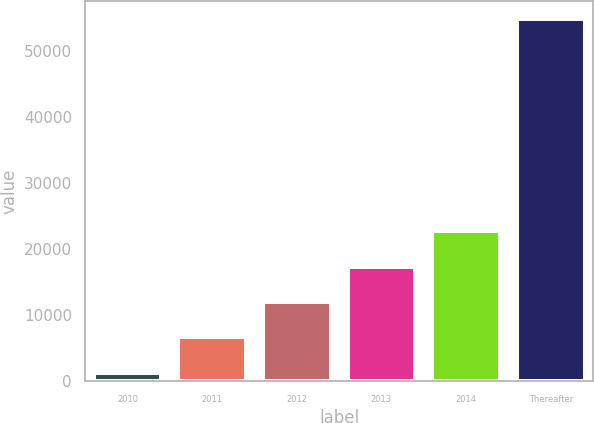<chart> <loc_0><loc_0><loc_500><loc_500><bar_chart><fcel>2010<fcel>2011<fcel>2012<fcel>2013<fcel>2014<fcel>Thereafter<nl><fcel>1308<fcel>6650.6<fcel>11993.2<fcel>17335.8<fcel>22678.4<fcel>54734<nl></chart> 